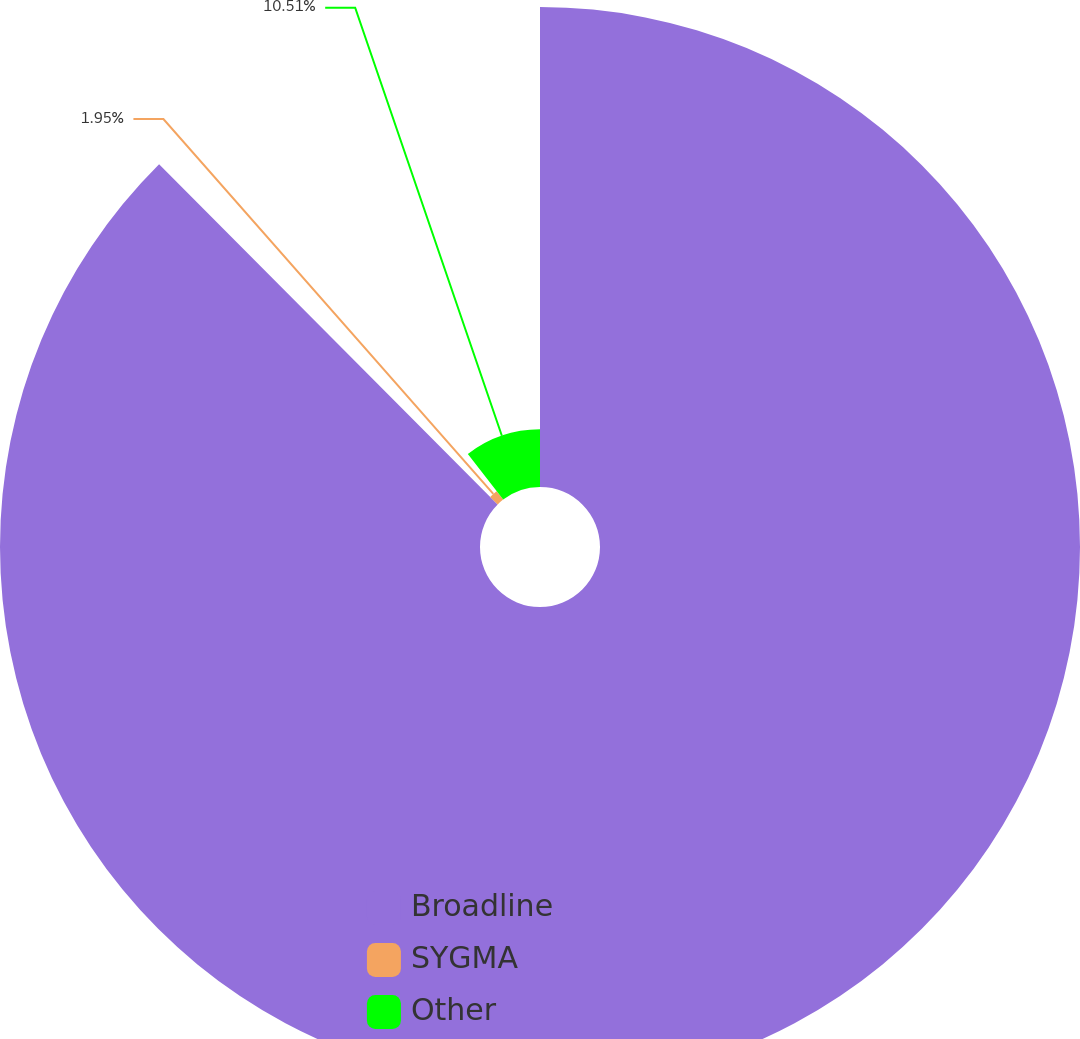Convert chart. <chart><loc_0><loc_0><loc_500><loc_500><pie_chart><fcel>Broadline<fcel>SYGMA<fcel>Other<nl><fcel>87.53%<fcel>1.95%<fcel>10.51%<nl></chart> 